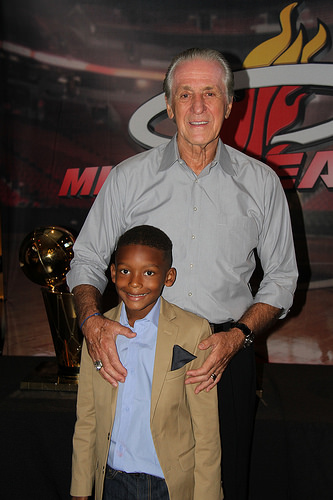<image>
Is there a sign behind the man? Yes. From this viewpoint, the sign is positioned behind the man, with the man partially or fully occluding the sign. 